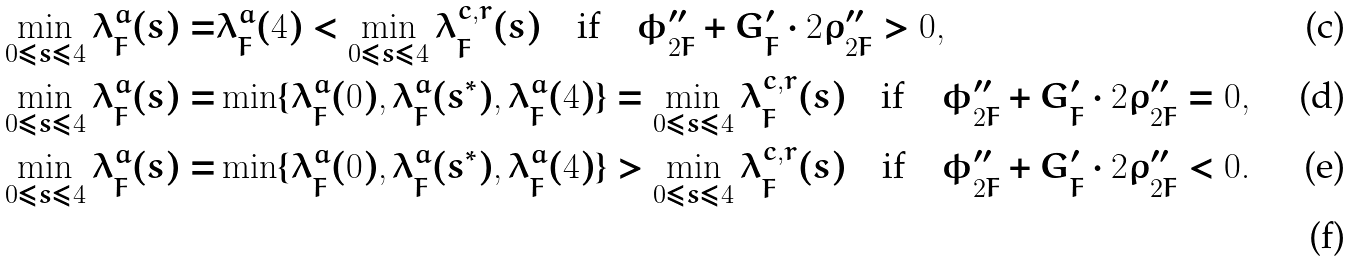<formula> <loc_0><loc_0><loc_500><loc_500>\min _ { 0 \leq s \leq 4 } \lambda ^ { a } _ { F } ( s ) = & \lambda ^ { a } _ { F } ( 4 ) < \min _ { 0 \leq s \leq 4 } \lambda ^ { c , r } _ { F } ( s ) \quad \text {if} \quad \phi ^ { \prime \prime } _ { 2 F } + G ^ { \prime } _ { F } \cdot 2 \rho ^ { \prime \prime } _ { 2 F } > 0 , \\ \min _ { 0 \leq s \leq 4 } \lambda ^ { a } _ { F } ( s ) = & \min \{ \lambda ^ { a } _ { F } ( 0 ) , \lambda ^ { a } _ { F } ( s ^ { * } ) , \lambda ^ { a } _ { F } ( 4 ) \} = \min _ { 0 \leq s \leq 4 } \lambda ^ { c , r } _ { F } ( s ) \quad \text {if} \quad \phi ^ { \prime \prime } _ { 2 F } + G ^ { \prime } _ { F } \cdot 2 \rho ^ { \prime \prime } _ { 2 F } = 0 , \\ \min _ { 0 \leq s \leq 4 } \lambda ^ { a } _ { F } ( s ) = & \min \{ \lambda ^ { a } _ { F } ( 0 ) , \lambda ^ { a } _ { F } ( s ^ { * } ) , \lambda ^ { a } _ { F } ( 4 ) \} > \min _ { 0 \leq s \leq 4 } \lambda ^ { c , r } _ { F } ( s ) \quad \text {if} \quad \phi ^ { \prime \prime } _ { 2 F } + G ^ { \prime } _ { F } \cdot 2 \rho ^ { \prime \prime } _ { 2 F } < 0 . \\</formula> 